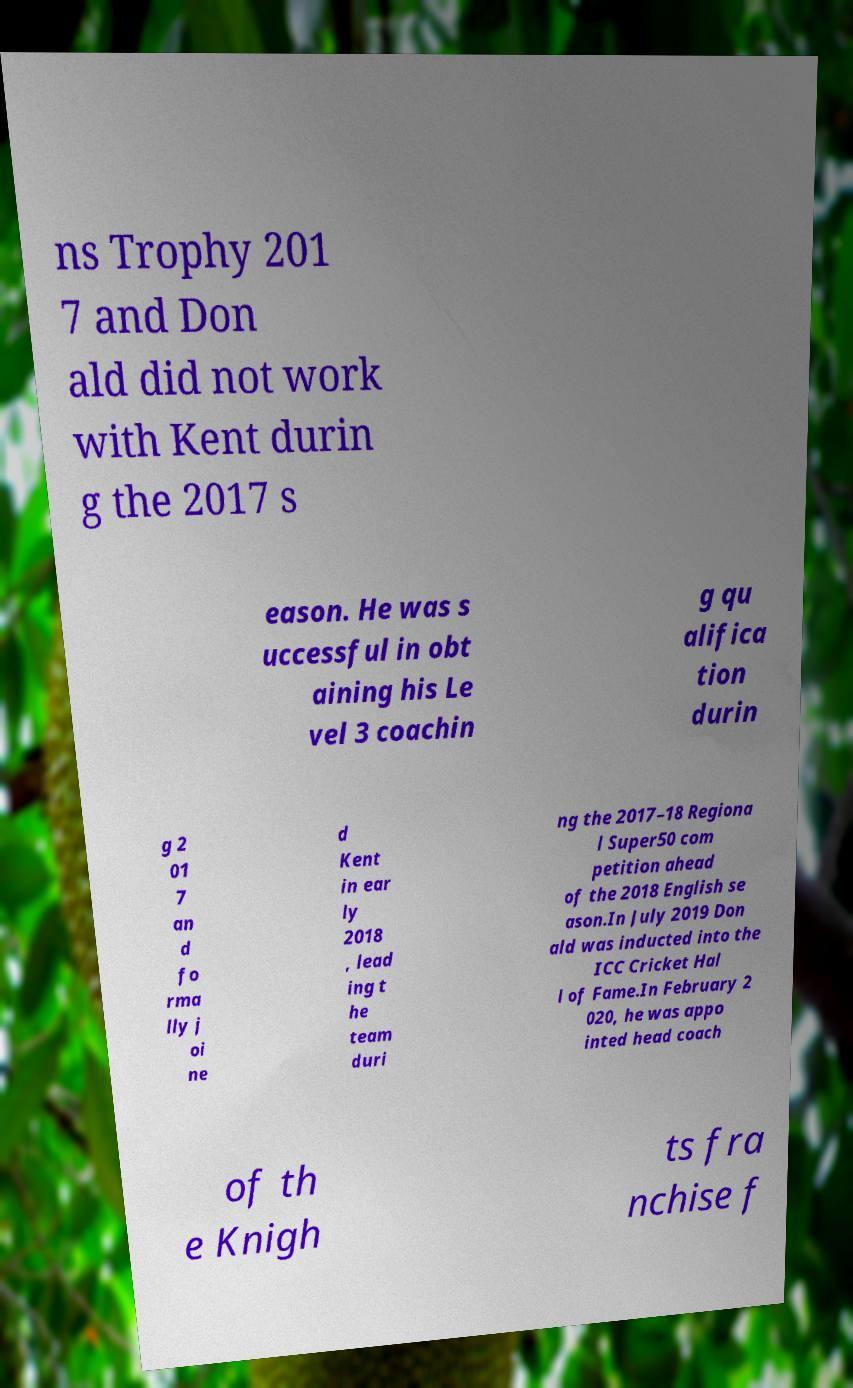Can you accurately transcribe the text from the provided image for me? ns Trophy 201 7 and Don ald did not work with Kent durin g the 2017 s eason. He was s uccessful in obt aining his Le vel 3 coachin g qu alifica tion durin g 2 01 7 an d fo rma lly j oi ne d Kent in ear ly 2018 , lead ing t he team duri ng the 2017–18 Regiona l Super50 com petition ahead of the 2018 English se ason.In July 2019 Don ald was inducted into the ICC Cricket Hal l of Fame.In February 2 020, he was appo inted head coach of th e Knigh ts fra nchise f 